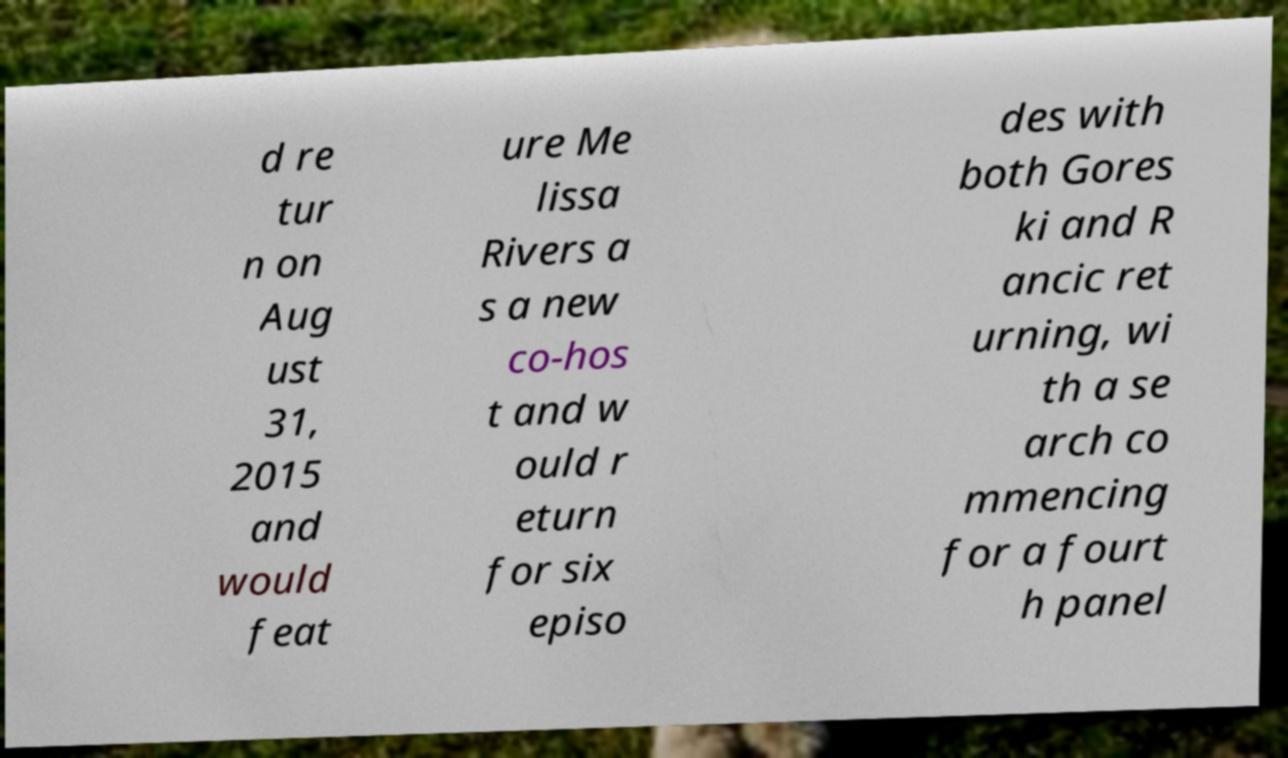There's text embedded in this image that I need extracted. Can you transcribe it verbatim? d re tur n on Aug ust 31, 2015 and would feat ure Me lissa Rivers a s a new co-hos t and w ould r eturn for six episo des with both Gores ki and R ancic ret urning, wi th a se arch co mmencing for a fourt h panel 